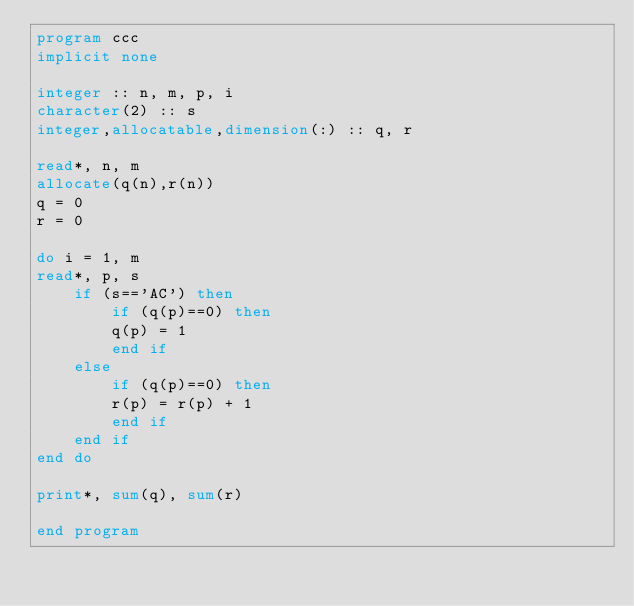<code> <loc_0><loc_0><loc_500><loc_500><_FORTRAN_>program ccc
implicit none

integer :: n, m, p, i
character(2) :: s
integer,allocatable,dimension(:) :: q, r

read*, n, m
allocate(q(n),r(n))
q = 0
r = 0

do i = 1, m
read*, p, s
	if (s=='AC') then
    	if (q(p)==0) then
        q(p) = 1
        end if
    else
    	if (q(p)==0) then
	    r(p) = r(p) + 1
        end if
    end if
end do

print*, sum(q), sum(r)

end program</code> 